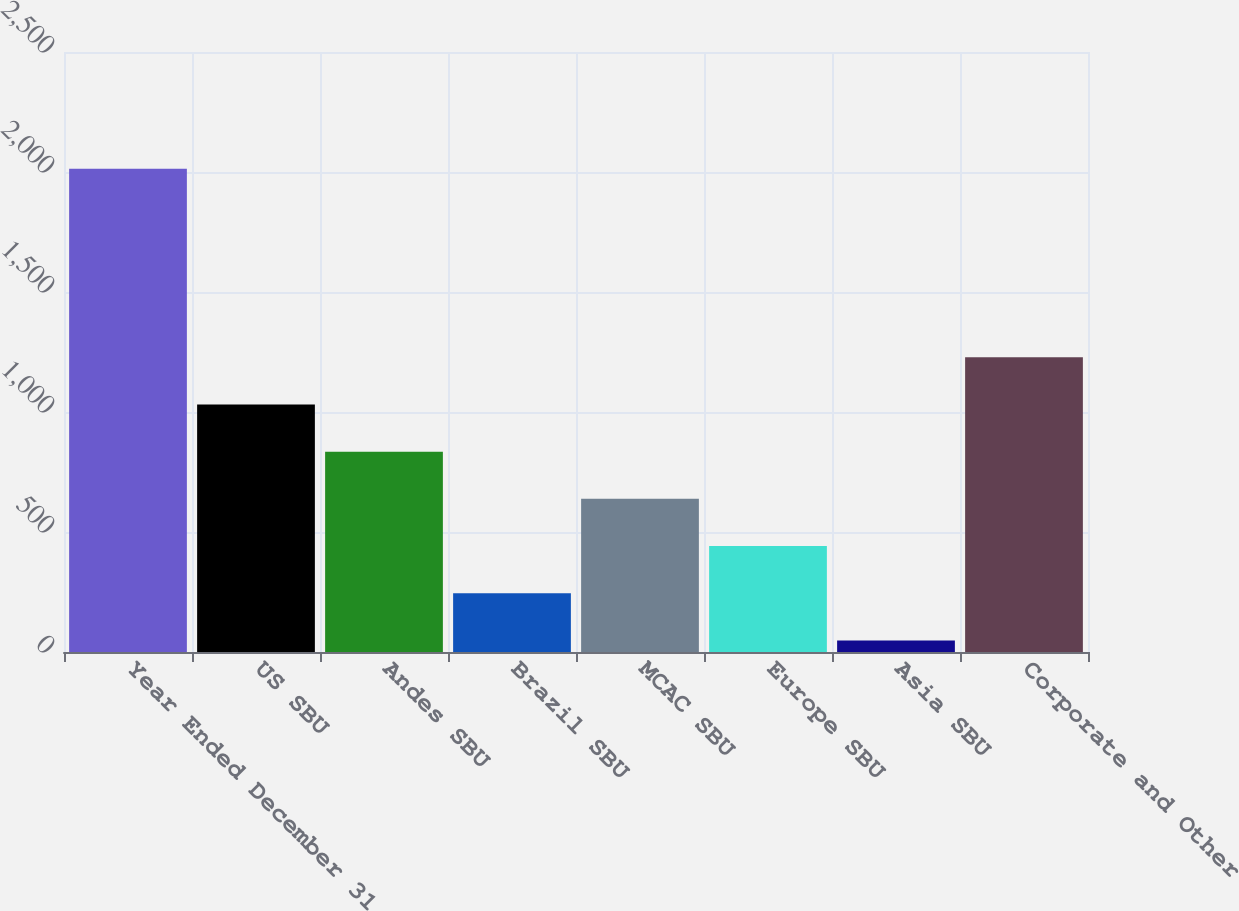Convert chart to OTSL. <chart><loc_0><loc_0><loc_500><loc_500><bar_chart><fcel>Year Ended December 31<fcel>US SBU<fcel>Andes SBU<fcel>Brazil SBU<fcel>MCAC SBU<fcel>Europe SBU<fcel>Asia SBU<fcel>Corporate and Other<nl><fcel>2014<fcel>1031.4<fcel>834.8<fcel>245<fcel>638.2<fcel>441.6<fcel>48<fcel>1228<nl></chart> 